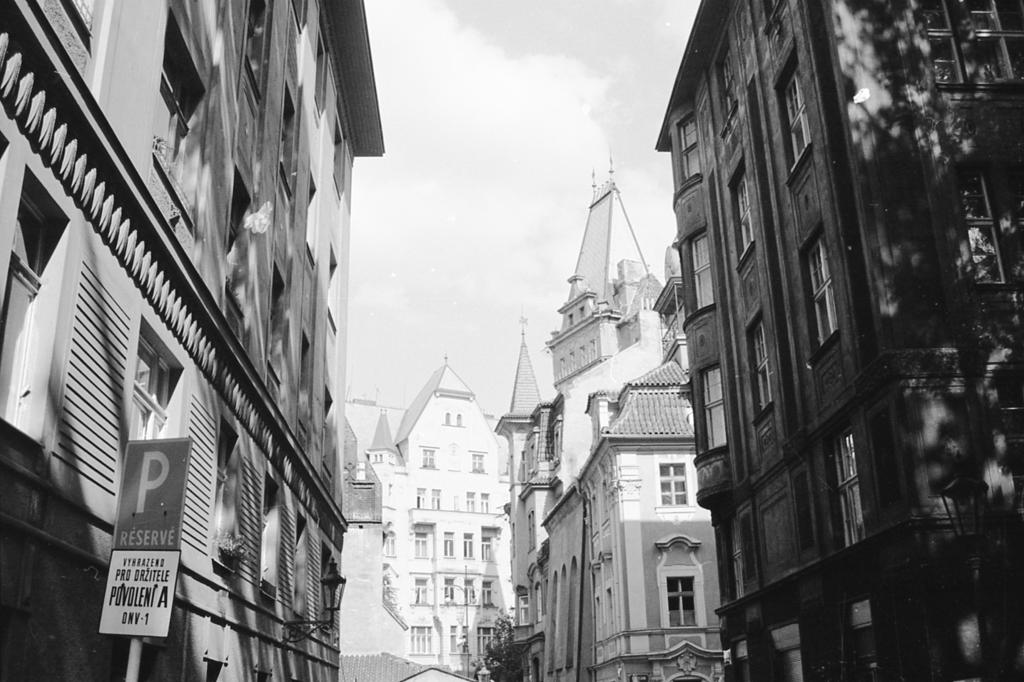What type of structures can be seen in the image? There are buildings in the image. What else can be seen besides the buildings? There are poles and sign boards visible in the image. What is visible at the top of the image? Clouds and the sky are visible at the top of the image. What type of punishment is being handed out by the clouds in the image? There is no punishment being handed out by the clouds in the image; they are simply visible in the sky. 